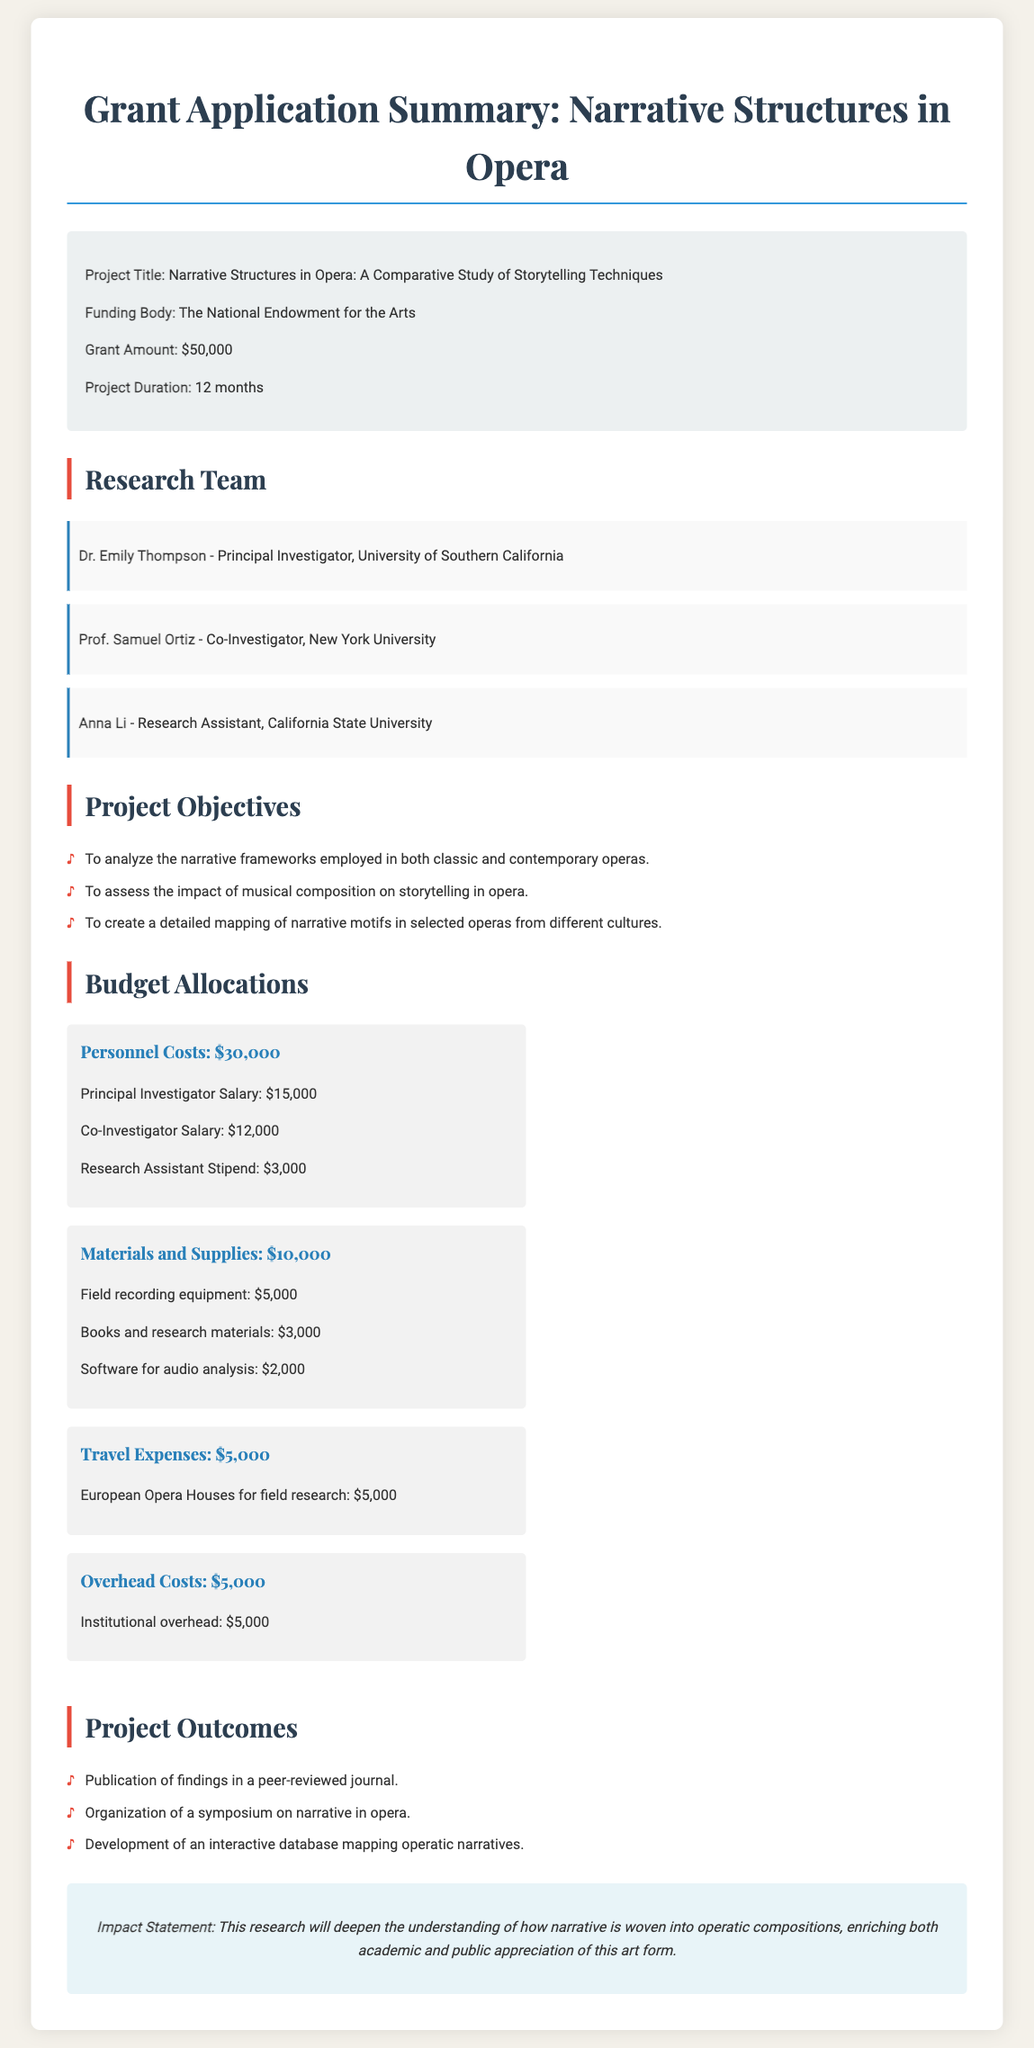What is the project title? The project title is listed in the grant info section of the document.
Answer: Narrative Structures in Opera: A Comparative Study of Storytelling Techniques Who is the principal investigator? The principal investigator's name is mentioned in the research team section of the document.
Answer: Dr. Emily Thompson What is the total grant amount? The total grant amount is specified in the grant info section of the document.
Answer: $50,000 How long is the project duration? The project duration is stated in the grant info section of the document.
Answer: 12 months What are the personnel costs? The personnel costs are detailed in the budget allocations section of the document.
Answer: $30,000 Which travel destination is specified for field research? The specific travel destination is mentioned in the travel expenses section of the budget allocations.
Answer: European Opera Houses What is one objective of the project? One of the objectives is listed in the project objectives section of the document.
Answer: To analyze the narrative frameworks employed in both classic and contemporary operas How much is allocated for materials and supplies? The amount allocated for materials and supplies is provided in the budget allocations.
Answer: $10,000 What is mentioned as a project outcome? One of the project outcomes is listed in the project outcomes section of the document.
Answer: Publication of findings in a peer-reviewed journal What is the impact statement? The impact statement is described at the end of the document in a specific section.
Answer: This research will deepen the understanding of how narrative is woven into operatic compositions, enriching both academic and public appreciation of this art form 